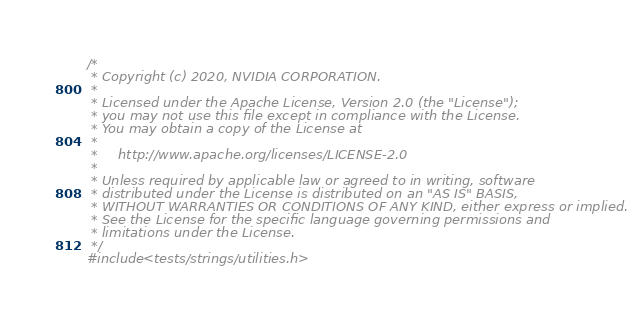<code> <loc_0><loc_0><loc_500><loc_500><_Cuda_>/*
 * Copyright (c) 2020, NVIDIA CORPORATION.
 *
 * Licensed under the Apache License, Version 2.0 (the "License");
 * you may not use this file except in compliance with the License.
 * You may obtain a copy of the License at
 *
 *     http://www.apache.org/licenses/LICENSE-2.0
 *
 * Unless required by applicable law or agreed to in writing, software
 * distributed under the License is distributed on an "AS IS" BASIS,
 * WITHOUT WARRANTIES OR CONDITIONS OF ANY KIND, either express or implied.
 * See the License for the specific language governing permissions and
 * limitations under the License.
 */
#include <tests/strings/utilities.h></code> 